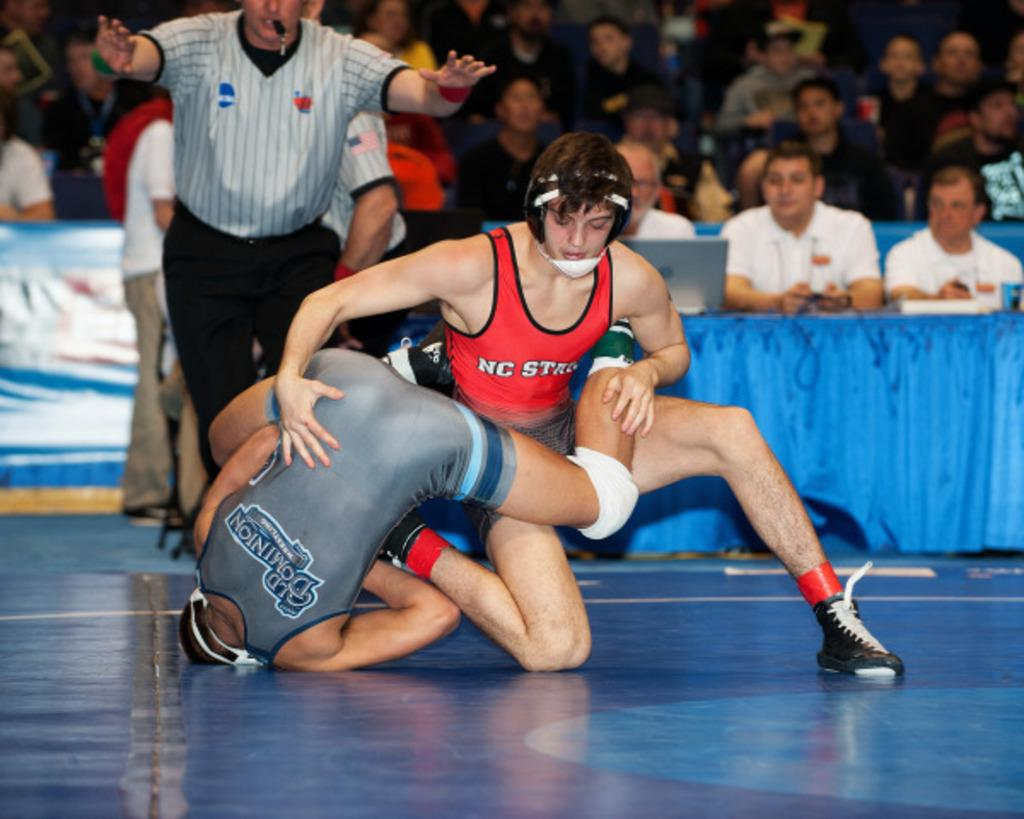<image>
Render a clear and concise summary of the photo. Two collegiate wrestlers, one from NC State wearing red singlet, are wrestling each other on the blue mat. 